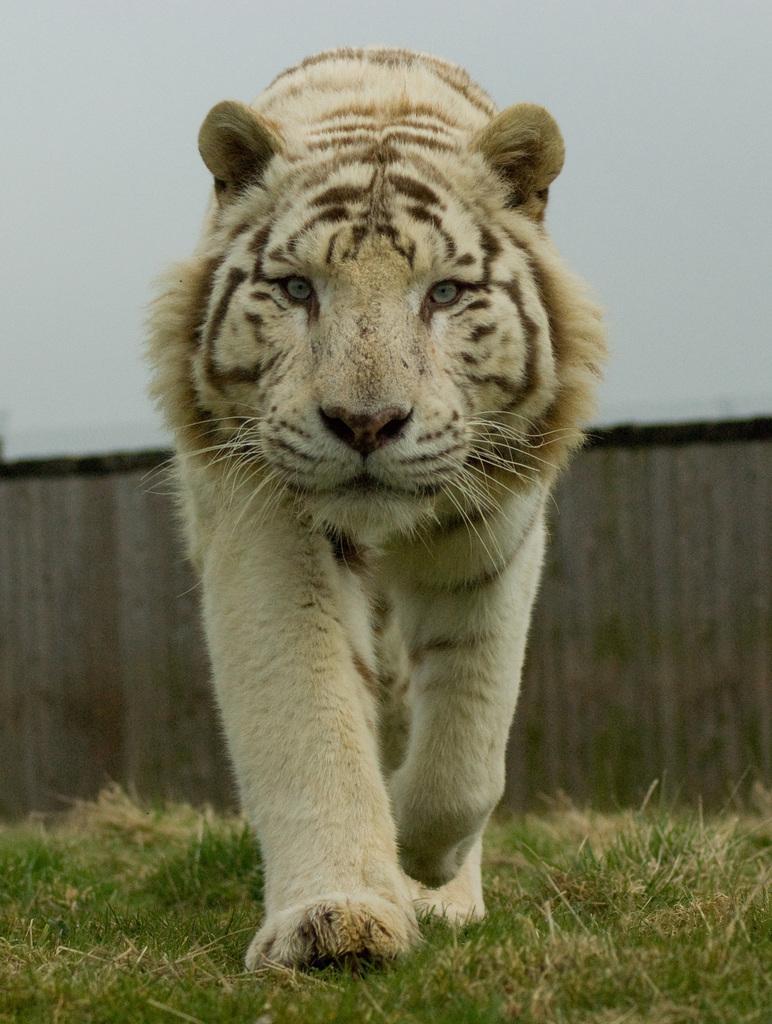In one or two sentences, can you explain what this image depicts? In this picture we can see a tiger, at the bottom there is grass, we can see a blurry background. 